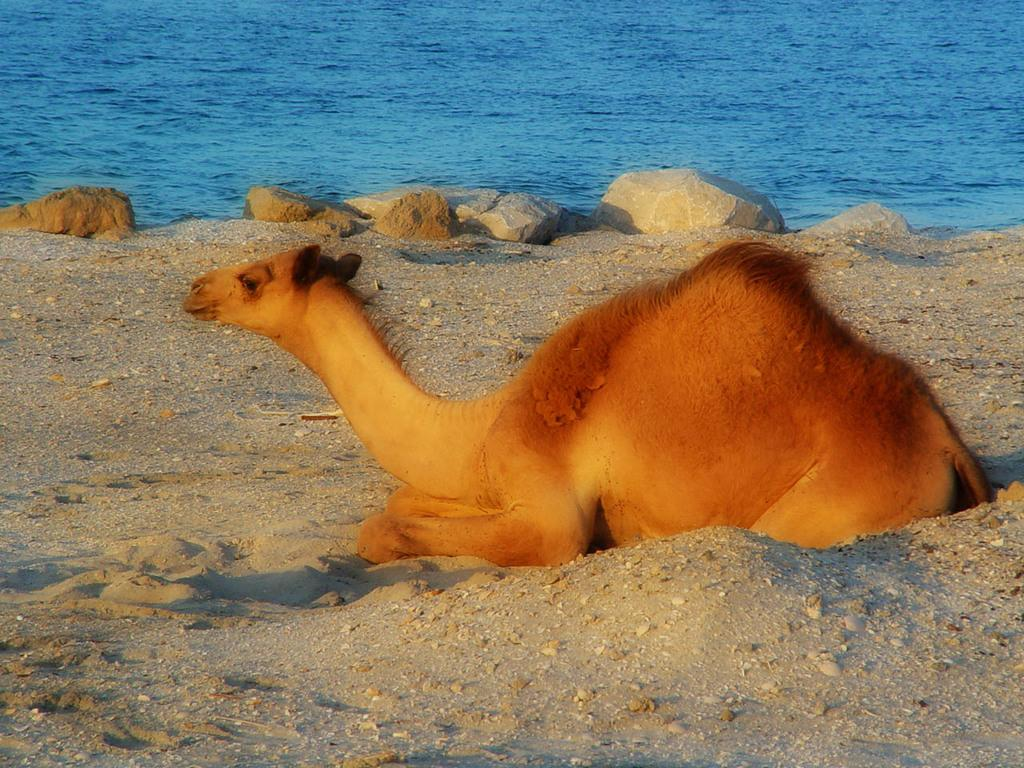What animal is the main subject of the image? There is a camel in the image. What is the camel doing in the image? The camel is sitting on the sand. What type of terrain is visible in the image? There are rocks in the image, and the camel is sitting on the sand. What can be seen in the background of the image? Water is present in the background of the image. What type of door can be seen in the image? There is no door present in the image; it features a camel sitting on the sand with rocks and water in the background. 